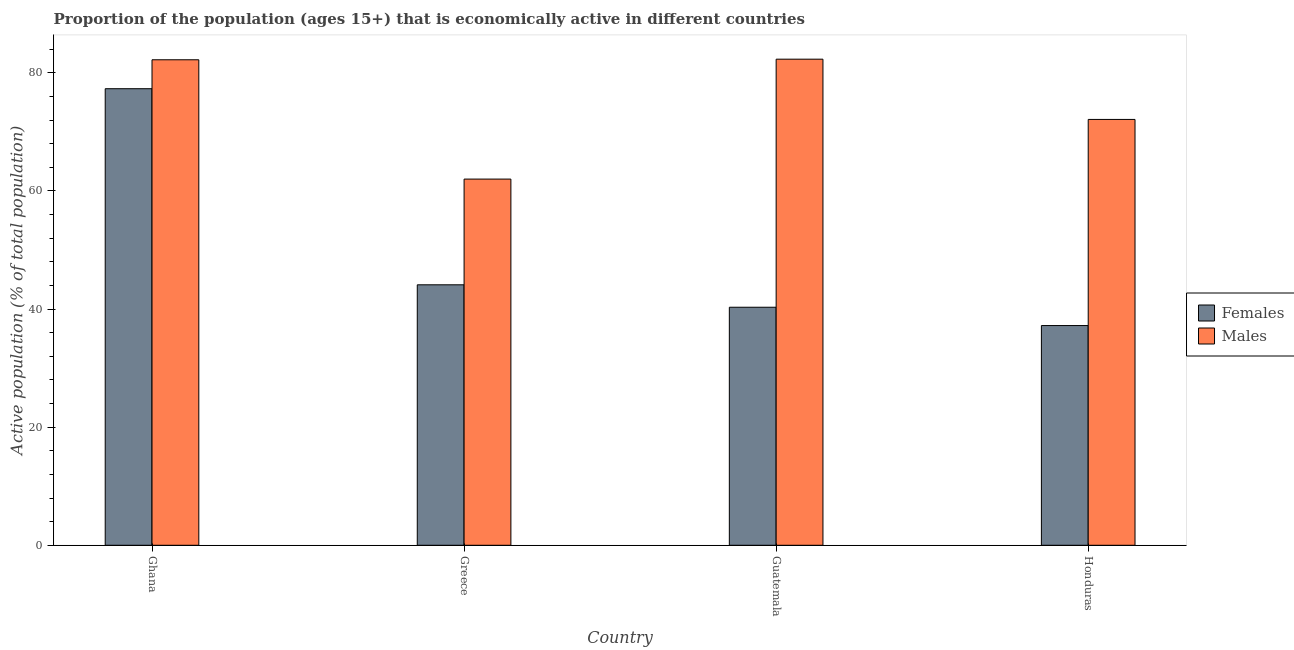How many different coloured bars are there?
Offer a terse response. 2. Are the number of bars per tick equal to the number of legend labels?
Provide a succinct answer. Yes. How many bars are there on the 3rd tick from the left?
Offer a very short reply. 2. What is the percentage of economically active female population in Guatemala?
Your response must be concise. 40.3. Across all countries, what is the maximum percentage of economically active male population?
Offer a terse response. 82.3. In which country was the percentage of economically active male population maximum?
Your answer should be very brief. Guatemala. In which country was the percentage of economically active female population minimum?
Provide a succinct answer. Honduras. What is the total percentage of economically active male population in the graph?
Give a very brief answer. 298.6. What is the difference between the percentage of economically active male population in Greece and that in Guatemala?
Make the answer very short. -20.3. What is the difference between the percentage of economically active male population in Honduras and the percentage of economically active female population in Guatemala?
Make the answer very short. 31.8. What is the average percentage of economically active female population per country?
Your response must be concise. 49.73. What is the difference between the percentage of economically active female population and percentage of economically active male population in Ghana?
Your answer should be very brief. -4.9. What is the ratio of the percentage of economically active female population in Guatemala to that in Honduras?
Offer a very short reply. 1.08. Is the percentage of economically active female population in Guatemala less than that in Honduras?
Your answer should be compact. No. Is the difference between the percentage of economically active female population in Greece and Guatemala greater than the difference between the percentage of economically active male population in Greece and Guatemala?
Your answer should be very brief. Yes. What is the difference between the highest and the second highest percentage of economically active male population?
Provide a succinct answer. 0.1. What is the difference between the highest and the lowest percentage of economically active female population?
Offer a terse response. 40.1. Is the sum of the percentage of economically active male population in Greece and Honduras greater than the maximum percentage of economically active female population across all countries?
Make the answer very short. Yes. What does the 2nd bar from the left in Greece represents?
Provide a short and direct response. Males. What does the 1st bar from the right in Guatemala represents?
Your response must be concise. Males. How many bars are there?
Provide a succinct answer. 8. Are the values on the major ticks of Y-axis written in scientific E-notation?
Make the answer very short. No. How many legend labels are there?
Provide a short and direct response. 2. How are the legend labels stacked?
Offer a very short reply. Vertical. What is the title of the graph?
Your answer should be very brief. Proportion of the population (ages 15+) that is economically active in different countries. Does "Netherlands" appear as one of the legend labels in the graph?
Make the answer very short. No. What is the label or title of the X-axis?
Ensure brevity in your answer.  Country. What is the label or title of the Y-axis?
Ensure brevity in your answer.  Active population (% of total population). What is the Active population (% of total population) of Females in Ghana?
Give a very brief answer. 77.3. What is the Active population (% of total population) of Males in Ghana?
Your answer should be very brief. 82.2. What is the Active population (% of total population) of Females in Greece?
Ensure brevity in your answer.  44.1. What is the Active population (% of total population) of Males in Greece?
Give a very brief answer. 62. What is the Active population (% of total population) in Females in Guatemala?
Offer a terse response. 40.3. What is the Active population (% of total population) in Males in Guatemala?
Provide a short and direct response. 82.3. What is the Active population (% of total population) in Females in Honduras?
Give a very brief answer. 37.2. What is the Active population (% of total population) in Males in Honduras?
Provide a short and direct response. 72.1. Across all countries, what is the maximum Active population (% of total population) of Females?
Offer a very short reply. 77.3. Across all countries, what is the maximum Active population (% of total population) of Males?
Offer a very short reply. 82.3. Across all countries, what is the minimum Active population (% of total population) in Females?
Make the answer very short. 37.2. Across all countries, what is the minimum Active population (% of total population) of Males?
Provide a succinct answer. 62. What is the total Active population (% of total population) of Females in the graph?
Keep it short and to the point. 198.9. What is the total Active population (% of total population) in Males in the graph?
Make the answer very short. 298.6. What is the difference between the Active population (% of total population) in Females in Ghana and that in Greece?
Your answer should be very brief. 33.2. What is the difference between the Active population (% of total population) of Males in Ghana and that in Greece?
Give a very brief answer. 20.2. What is the difference between the Active population (% of total population) of Females in Ghana and that in Guatemala?
Provide a succinct answer. 37. What is the difference between the Active population (% of total population) of Females in Ghana and that in Honduras?
Your answer should be compact. 40.1. What is the difference between the Active population (% of total population) of Males in Ghana and that in Honduras?
Your answer should be compact. 10.1. What is the difference between the Active population (% of total population) of Males in Greece and that in Guatemala?
Your response must be concise. -20.3. What is the difference between the Active population (% of total population) in Females in Greece and that in Honduras?
Provide a succinct answer. 6.9. What is the difference between the Active population (% of total population) of Females in Guatemala and that in Honduras?
Your answer should be very brief. 3.1. What is the difference between the Active population (% of total population) of Males in Guatemala and that in Honduras?
Provide a short and direct response. 10.2. What is the difference between the Active population (% of total population) of Females in Ghana and the Active population (% of total population) of Males in Guatemala?
Offer a very short reply. -5. What is the difference between the Active population (% of total population) of Females in Greece and the Active population (% of total population) of Males in Guatemala?
Give a very brief answer. -38.2. What is the difference between the Active population (% of total population) of Females in Greece and the Active population (% of total population) of Males in Honduras?
Give a very brief answer. -28. What is the difference between the Active population (% of total population) of Females in Guatemala and the Active population (% of total population) of Males in Honduras?
Provide a succinct answer. -31.8. What is the average Active population (% of total population) in Females per country?
Offer a terse response. 49.73. What is the average Active population (% of total population) of Males per country?
Your answer should be compact. 74.65. What is the difference between the Active population (% of total population) in Females and Active population (% of total population) in Males in Ghana?
Your answer should be compact. -4.9. What is the difference between the Active population (% of total population) of Females and Active population (% of total population) of Males in Greece?
Your answer should be very brief. -17.9. What is the difference between the Active population (% of total population) in Females and Active population (% of total population) in Males in Guatemala?
Offer a very short reply. -42. What is the difference between the Active population (% of total population) of Females and Active population (% of total population) of Males in Honduras?
Provide a succinct answer. -34.9. What is the ratio of the Active population (% of total population) of Females in Ghana to that in Greece?
Provide a short and direct response. 1.75. What is the ratio of the Active population (% of total population) of Males in Ghana to that in Greece?
Give a very brief answer. 1.33. What is the ratio of the Active population (% of total population) of Females in Ghana to that in Guatemala?
Your answer should be very brief. 1.92. What is the ratio of the Active population (% of total population) in Females in Ghana to that in Honduras?
Keep it short and to the point. 2.08. What is the ratio of the Active population (% of total population) in Males in Ghana to that in Honduras?
Offer a very short reply. 1.14. What is the ratio of the Active population (% of total population) in Females in Greece to that in Guatemala?
Offer a terse response. 1.09. What is the ratio of the Active population (% of total population) in Males in Greece to that in Guatemala?
Give a very brief answer. 0.75. What is the ratio of the Active population (% of total population) in Females in Greece to that in Honduras?
Keep it short and to the point. 1.19. What is the ratio of the Active population (% of total population) of Males in Greece to that in Honduras?
Provide a succinct answer. 0.86. What is the ratio of the Active population (% of total population) of Females in Guatemala to that in Honduras?
Provide a succinct answer. 1.08. What is the ratio of the Active population (% of total population) in Males in Guatemala to that in Honduras?
Keep it short and to the point. 1.14. What is the difference between the highest and the second highest Active population (% of total population) of Females?
Offer a very short reply. 33.2. What is the difference between the highest and the second highest Active population (% of total population) in Males?
Give a very brief answer. 0.1. What is the difference between the highest and the lowest Active population (% of total population) in Females?
Make the answer very short. 40.1. What is the difference between the highest and the lowest Active population (% of total population) of Males?
Your answer should be compact. 20.3. 